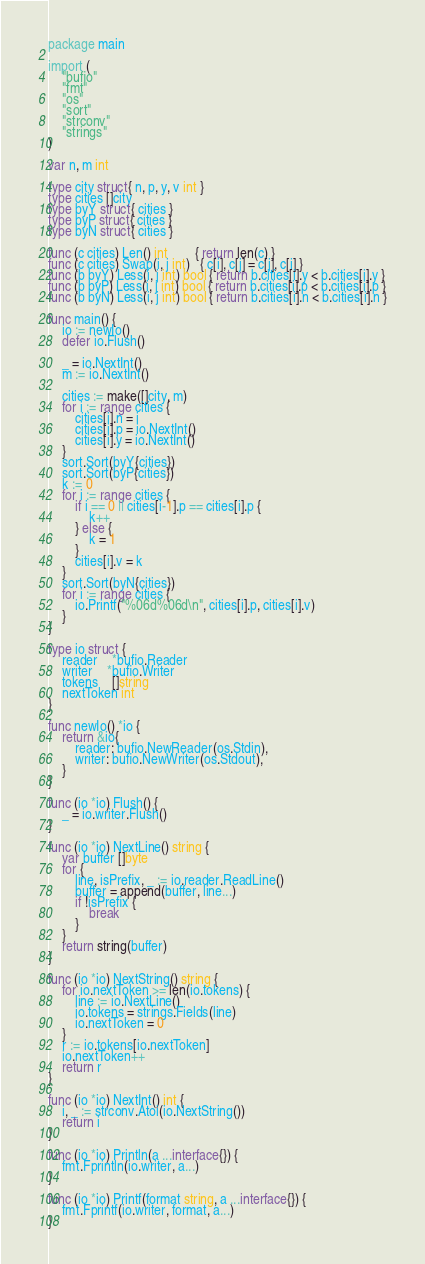<code> <loc_0><loc_0><loc_500><loc_500><_Go_>package main

import (
	"bufio"
	"fmt"
	"os"
	"sort"
	"strconv"
	"strings"
)

var n, m int

type city struct{ n, p, y, v int }
type cities []city
type byY struct{ cities }
type byP struct{ cities }
type byN struct{ cities }

func (c cities) Len() int        { return len(c) }
func (c cities) Swap(i, j int)   { c[i], c[j] = c[j], c[i] }
func (b byY) Less(i, j int) bool { return b.cities[i].y < b.cities[i].y }
func (b byP) Less(i, j int) bool { return b.cities[i].p < b.cities[i].p }
func (b byN) Less(i, j int) bool { return b.cities[i].n < b.cities[i].n }

func main() {
	io := newIo()
	defer io.Flush()

	_ = io.NextInt()
	m := io.NextInt()

	cities := make([]city, m)
	for i := range cities {
		cities[i].n = i
		cities[i].p = io.NextInt()
		cities[i].y = io.NextInt()
	}
	sort.Sort(byY{cities})
	sort.Sort(byP{cities})
	k := 0
	for i := range cities {
		if i == 0 || cities[i-1].p == cities[i].p {
			k++
		} else {
			k = 1
		}
		cities[i].v = k
	}
	sort.Sort(byN{cities})
	for i := range cities {
		io.Printf("%06d%06d\n", cities[i].p, cities[i].v)
	}
}

type io struct {
	reader    *bufio.Reader
	writer    *bufio.Writer
	tokens    []string
	nextToken int
}

func newIo() *io {
	return &io{
		reader: bufio.NewReader(os.Stdin),
		writer: bufio.NewWriter(os.Stdout),
	}
}

func (io *io) Flush() {
	_ = io.writer.Flush()
}

func (io *io) NextLine() string {
	var buffer []byte
	for {
		line, isPrefix, _ := io.reader.ReadLine()
		buffer = append(buffer, line...)
		if !isPrefix {
			break
		}
	}
	return string(buffer)
}

func (io *io) NextString() string {
	for io.nextToken >= len(io.tokens) {
		line := io.NextLine()
		io.tokens = strings.Fields(line)
		io.nextToken = 0
	}
	r := io.tokens[io.nextToken]
	io.nextToken++
	return r
}

func (io *io) NextInt() int {
	i, _ := strconv.Atoi(io.NextString())
	return i
}

func (io *io) Println(a ...interface{}) {
	fmt.Fprintln(io.writer, a...)
}

func (io *io) Printf(format string, a ...interface{}) {
	fmt.Fprintf(io.writer, format, a...)
}
</code> 